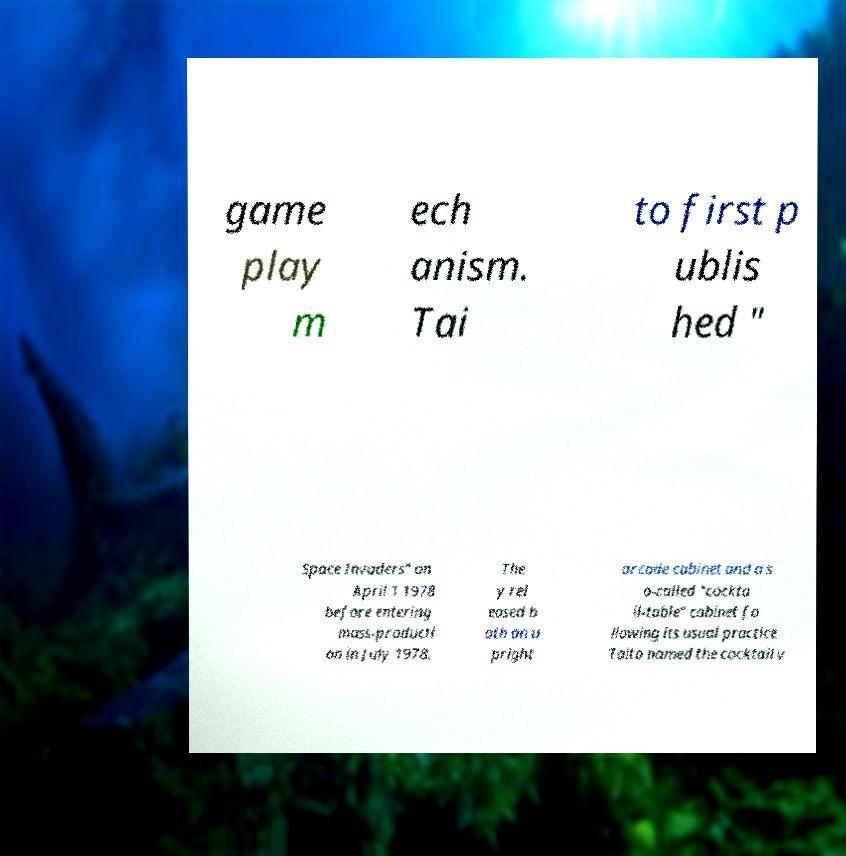There's text embedded in this image that I need extracted. Can you transcribe it verbatim? game play m ech anism. Tai to first p ublis hed " Space Invaders" on April 1 1978 before entering mass-producti on in July 1978. The y rel eased b oth an u pright arcade cabinet and a s o-called "cockta il-table" cabinet fo llowing its usual practice Taito named the cocktail v 